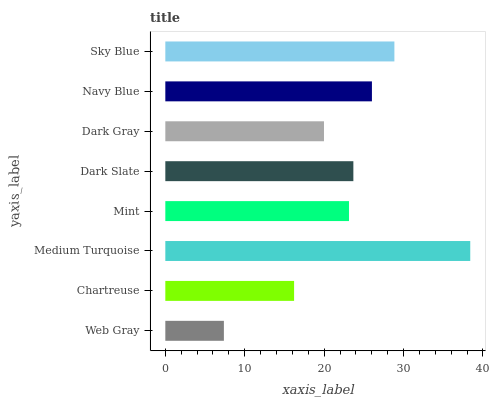Is Web Gray the minimum?
Answer yes or no. Yes. Is Medium Turquoise the maximum?
Answer yes or no. Yes. Is Chartreuse the minimum?
Answer yes or no. No. Is Chartreuse the maximum?
Answer yes or no. No. Is Chartreuse greater than Web Gray?
Answer yes or no. Yes. Is Web Gray less than Chartreuse?
Answer yes or no. Yes. Is Web Gray greater than Chartreuse?
Answer yes or no. No. Is Chartreuse less than Web Gray?
Answer yes or no. No. Is Dark Slate the high median?
Answer yes or no. Yes. Is Mint the low median?
Answer yes or no. Yes. Is Navy Blue the high median?
Answer yes or no. No. Is Navy Blue the low median?
Answer yes or no. No. 